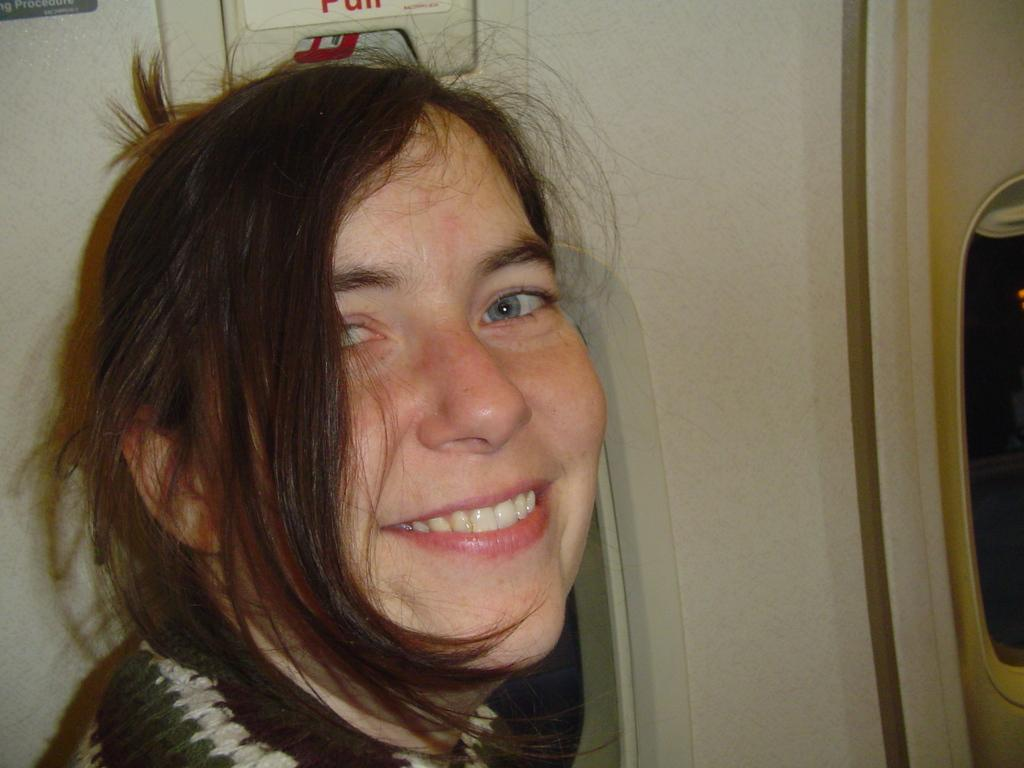Who is present in the image? There is a woman in the image. What is the woman doing in the image? The woman is smiling in the image. Where is the woman located in the image? The woman is in a vehicle in the image. What type of glue is being used by the woman in the image? There is no glue present in the image, and the woman is not using any glue. 